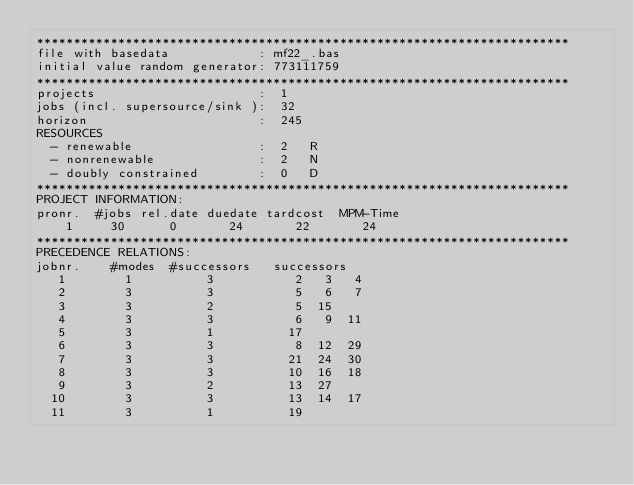Convert code to text. <code><loc_0><loc_0><loc_500><loc_500><_ObjectiveC_>************************************************************************
file with basedata            : mf22_.bas
initial value random generator: 773111759
************************************************************************
projects                      :  1
jobs (incl. supersource/sink ):  32
horizon                       :  245
RESOURCES
  - renewable                 :  2   R
  - nonrenewable              :  2   N
  - doubly constrained        :  0   D
************************************************************************
PROJECT INFORMATION:
pronr.  #jobs rel.date duedate tardcost  MPM-Time
    1     30      0       24       22       24
************************************************************************
PRECEDENCE RELATIONS:
jobnr.    #modes  #successors   successors
   1        1          3           2   3   4
   2        3          3           5   6   7
   3        3          2           5  15
   4        3          3           6   9  11
   5        3          1          17
   6        3          3           8  12  29
   7        3          3          21  24  30
   8        3          3          10  16  18
   9        3          2          13  27
  10        3          3          13  14  17
  11        3          1          19</code> 